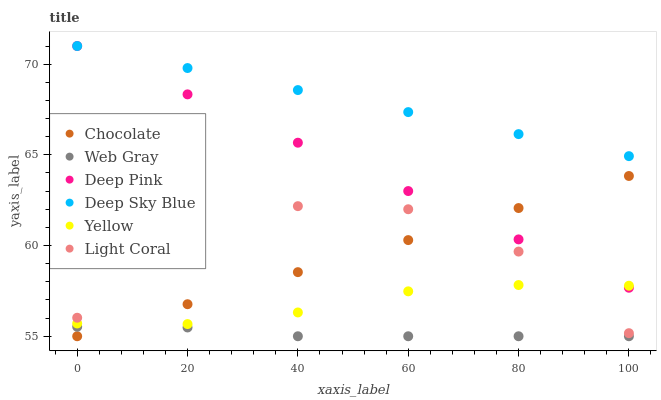Does Web Gray have the minimum area under the curve?
Answer yes or no. Yes. Does Deep Sky Blue have the maximum area under the curve?
Answer yes or no. Yes. Does Yellow have the minimum area under the curve?
Answer yes or no. No. Does Yellow have the maximum area under the curve?
Answer yes or no. No. Is Chocolate the smoothest?
Answer yes or no. Yes. Is Light Coral the roughest?
Answer yes or no. Yes. Is Yellow the smoothest?
Answer yes or no. No. Is Yellow the roughest?
Answer yes or no. No. Does Web Gray have the lowest value?
Answer yes or no. Yes. Does Yellow have the lowest value?
Answer yes or no. No. Does Deep Sky Blue have the highest value?
Answer yes or no. Yes. Does Yellow have the highest value?
Answer yes or no. No. Is Web Gray less than Yellow?
Answer yes or no. Yes. Is Deep Sky Blue greater than Light Coral?
Answer yes or no. Yes. Does Light Coral intersect Chocolate?
Answer yes or no. Yes. Is Light Coral less than Chocolate?
Answer yes or no. No. Is Light Coral greater than Chocolate?
Answer yes or no. No. Does Web Gray intersect Yellow?
Answer yes or no. No. 